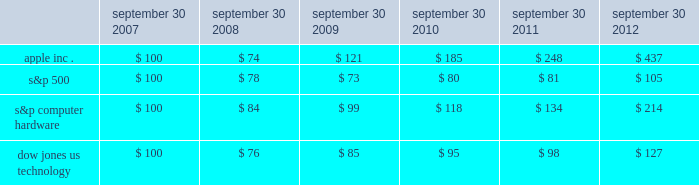Company stock performance the following graph shows a five-year comparison of cumulative total shareholder return , calculated on a dividend reinvested basis , for the company , the s&p 500 composite index , the s&p computer hardware index , and the dow jones u.s .
Technology index .
The graph assumes $ 100 was invested in each of the company 2019s common stock , the s&p 500 composite index , the s&p computer hardware index , and the dow jones u.s .
Technology index as of the market close on september 30 , 2007 .
Data points on the graph are annual .
Note that historic stock price performance is not necessarily indicative of future stock price performance .
Sep-11sep-10sep-09sep-08sep-07 sep-12 apple inc .
S&p 500 s&p computer hardware dow jones us technology comparison of 5 year cumulative total return* among apple inc. , the s&p 500 index , the s&p computer hardware index , and the dow jones us technology index *$ 100 invested on 9/30/07 in stock or index , including reinvestment of dividends .
Fiscal year ending september 30 .
Copyright a9 2012 s&p , a division of the mcgraw-hill companies inc .
All rights reserved .
September 30 , september 30 , september 30 , september 30 , september 30 , september 30 .

What was the cumulative total return on the s&p 500 between september 30 2007 and september 30 2012? 
Computations: (105 - 100)
Answer: 5.0. 